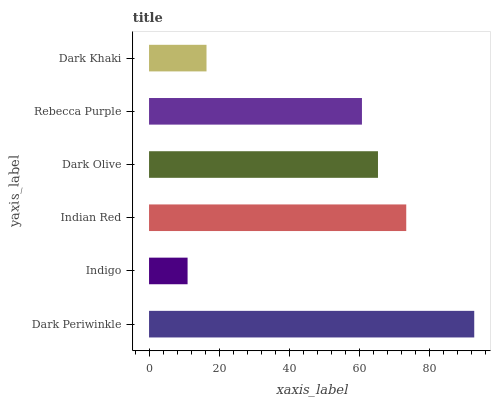Is Indigo the minimum?
Answer yes or no. Yes. Is Dark Periwinkle the maximum?
Answer yes or no. Yes. Is Indian Red the minimum?
Answer yes or no. No. Is Indian Red the maximum?
Answer yes or no. No. Is Indian Red greater than Indigo?
Answer yes or no. Yes. Is Indigo less than Indian Red?
Answer yes or no. Yes. Is Indigo greater than Indian Red?
Answer yes or no. No. Is Indian Red less than Indigo?
Answer yes or no. No. Is Dark Olive the high median?
Answer yes or no. Yes. Is Rebecca Purple the low median?
Answer yes or no. Yes. Is Dark Khaki the high median?
Answer yes or no. No. Is Dark Periwinkle the low median?
Answer yes or no. No. 